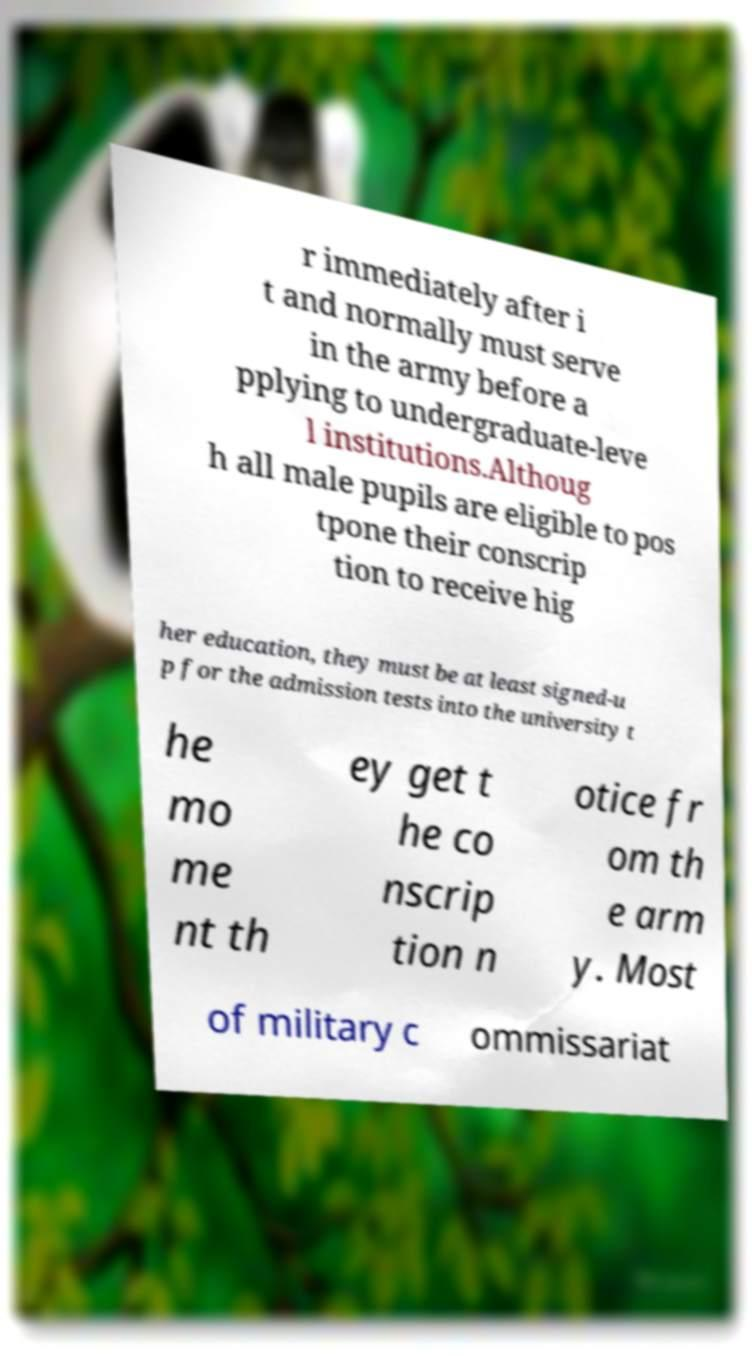Could you assist in decoding the text presented in this image and type it out clearly? r immediately after i t and normally must serve in the army before a pplying to undergraduate-leve l institutions.Althoug h all male pupils are eligible to pos tpone their conscrip tion to receive hig her education, they must be at least signed-u p for the admission tests into the university t he mo me nt th ey get t he co nscrip tion n otice fr om th e arm y. Most of military c ommissariat 